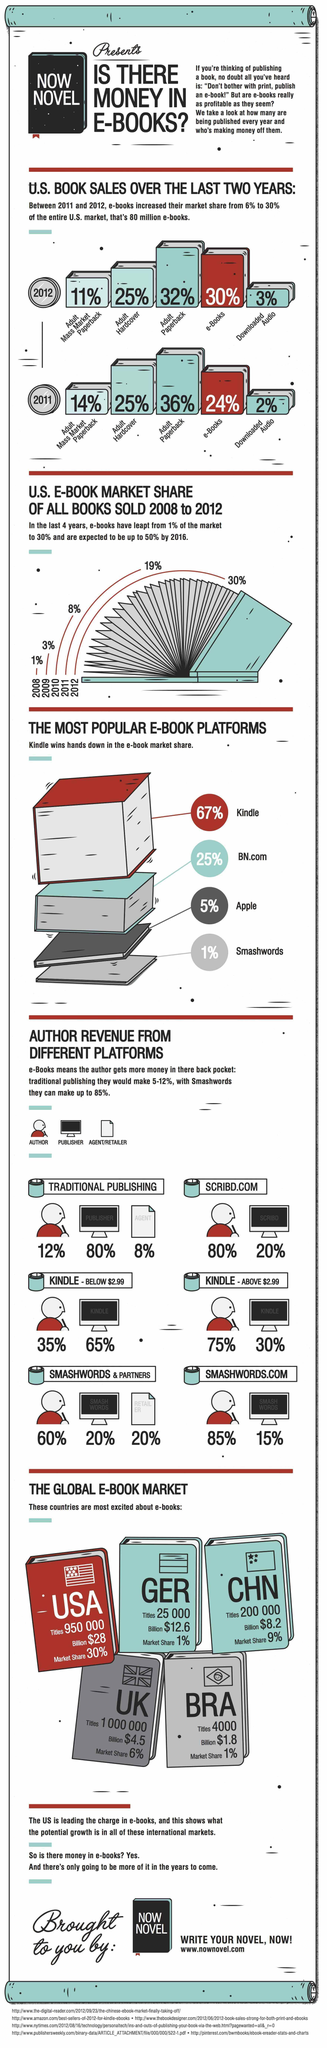Point out several critical features in this image. The author earns the highest revenue through the publishing platform of Smashwords.com. In Germany, approximately 25,000 titles were published. In the United Kingdom, the market share of e-books is 6%. In 2009, the market share of e-books was 3%. E-books account for 9% of the market in China. 